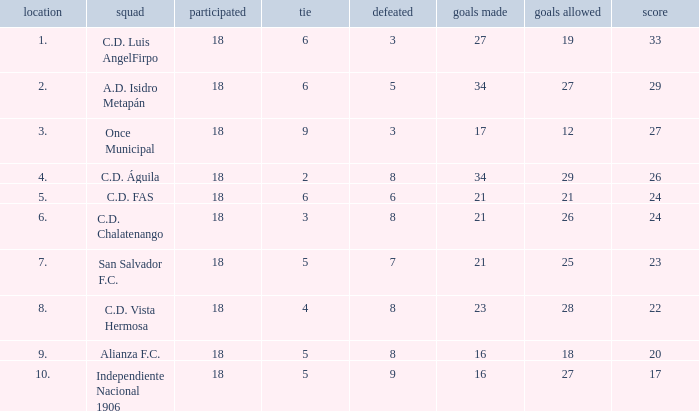What are the number of goals conceded that has a played greater than 18? 0.0. 